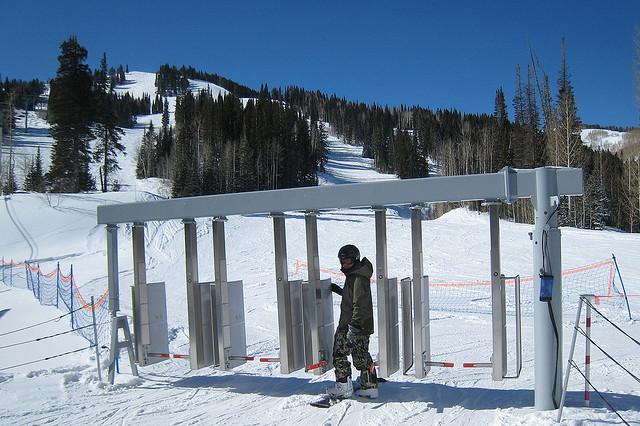What sport is this person participating in?
Answer briefly. Skiing. What is the person holding on to?
Write a very short answer. Gate. Is all the ground level?
Answer briefly. No. 